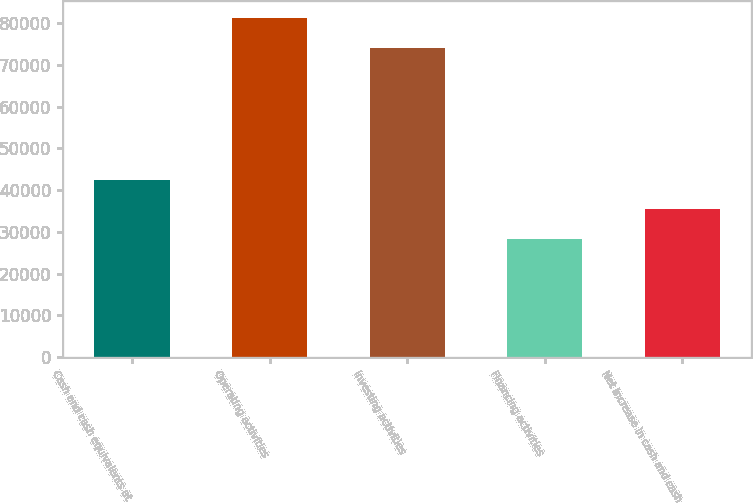Convert chart. <chart><loc_0><loc_0><loc_500><loc_500><bar_chart><fcel>Cash and cash equivalents at<fcel>Operating activities<fcel>Investing activities<fcel>Financing activities<fcel>Net increase in cash and cash<nl><fcel>42517.8<fcel>81201.4<fcel>74061<fcel>28237<fcel>35377.4<nl></chart> 